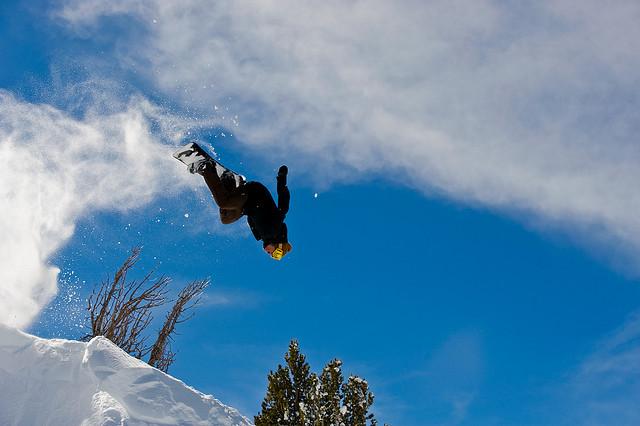Is the man flying in the sky?
Be succinct. No. Does the person has wings?
Write a very short answer. No. Is it a nice day?
Answer briefly. Yes. What type of clouds are in the sky?
Concise answer only. White. 